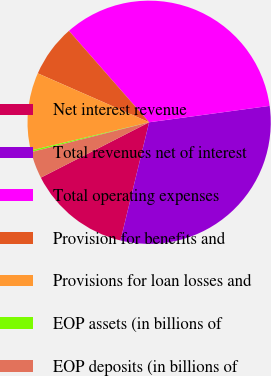Convert chart. <chart><loc_0><loc_0><loc_500><loc_500><pie_chart><fcel>Net interest revenue<fcel>Total revenues net of interest<fcel>Total operating expenses<fcel>Provision for benefits and<fcel>Provisions for loan losses and<fcel>EOP assets (in billions of<fcel>EOP deposits (in billions of<nl><fcel>13.69%<fcel>30.93%<fcel>34.3%<fcel>6.95%<fcel>10.32%<fcel>0.21%<fcel>3.58%<nl></chart> 